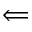<formula> <loc_0><loc_0><loc_500><loc_500>\Longleftarrow</formula> 